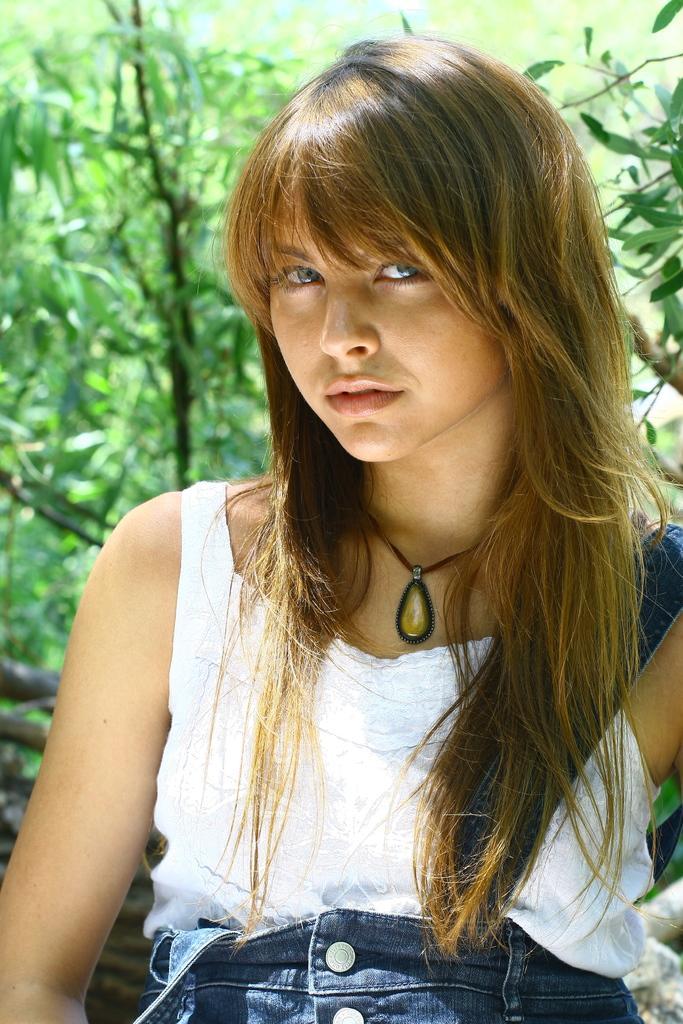How would you summarize this image in a sentence or two? In this image, I can see the woman standing and smiling. She wore a dress and a necklace. In the background, I can see the trees, which are green in color. 